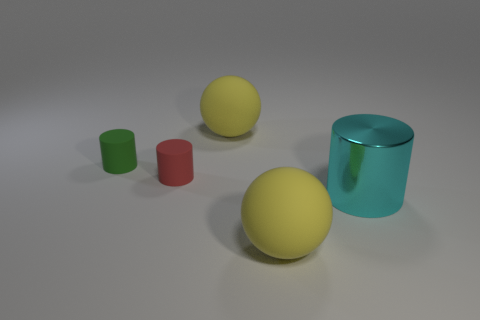What size is the thing that is in front of the small red cylinder and to the left of the cyan shiny cylinder? The object in front of the small red cylinder and to the left of the cyan cylinder appears to be a large yellow sphere, approximately twice the diameter of the red cylinder itself. 